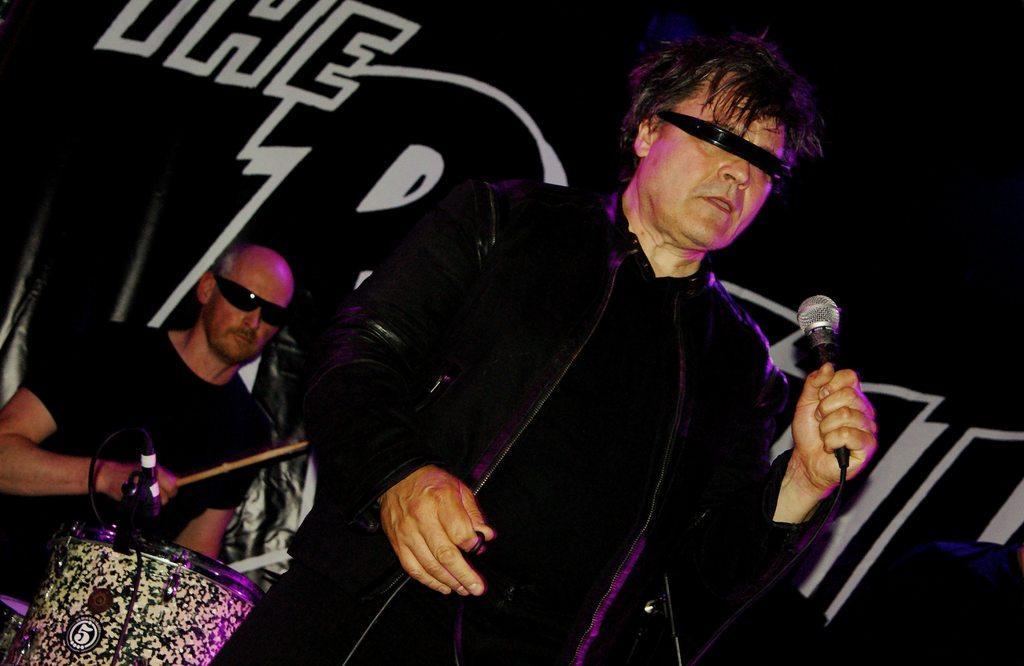Describe this image in one or two sentences. Here we can see a man standing, and holding a microphone in his hand, and at back a person is sitting and playing the drums. 